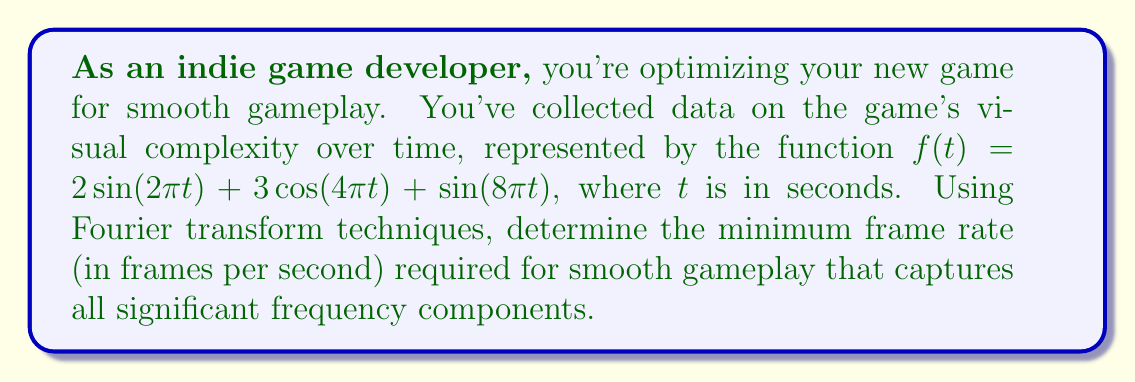Help me with this question. To solve this problem, we'll follow these steps:

1) First, we need to identify the frequency components in the given function. The Fourier transform helps us decompose the function into its constituent frequencies.

2) In the function $f(t) = 2\sin(2\pi t) + 3\cos(4\pi t) + \sin(8\pi t)$, we can identify three frequency components:

   - $2\pi t$ corresponds to a frequency of 1 Hz
   - $4\pi t$ corresponds to a frequency of 2 Hz
   - $8\pi t$ corresponds to a frequency of 4 Hz

3) The highest frequency component is 4 Hz.

4) According to the Nyquist-Shannon sampling theorem, to accurately represent a signal, we need to sample at a rate of at least twice the highest frequency component.

5) Therefore, the minimum sampling rate is:

   $$f_{sample} = 2 \times f_{max} = 2 \times 4 \text{ Hz} = 8 \text{ Hz}$$

6) In the context of game development, the sampling rate corresponds to the frame rate. However, for smooth gameplay, we typically want a higher frame rate than the bare minimum.

7) A common practice is to use a frame rate that's about 1.5 to 2 times the minimum required rate for smoother visuals.

8) Therefore, we'll multiply our minimum rate by 1.5:

   $$f_{frame} = 1.5 \times f_{sample} = 1.5 \times 8 \text{ fps} = 12 \text{ fps}$$

9) Since we're dealing with frame rates, we'll round up to the nearest whole number.
Answer: The optimal frame rate for smooth gameplay is 12 fps. 